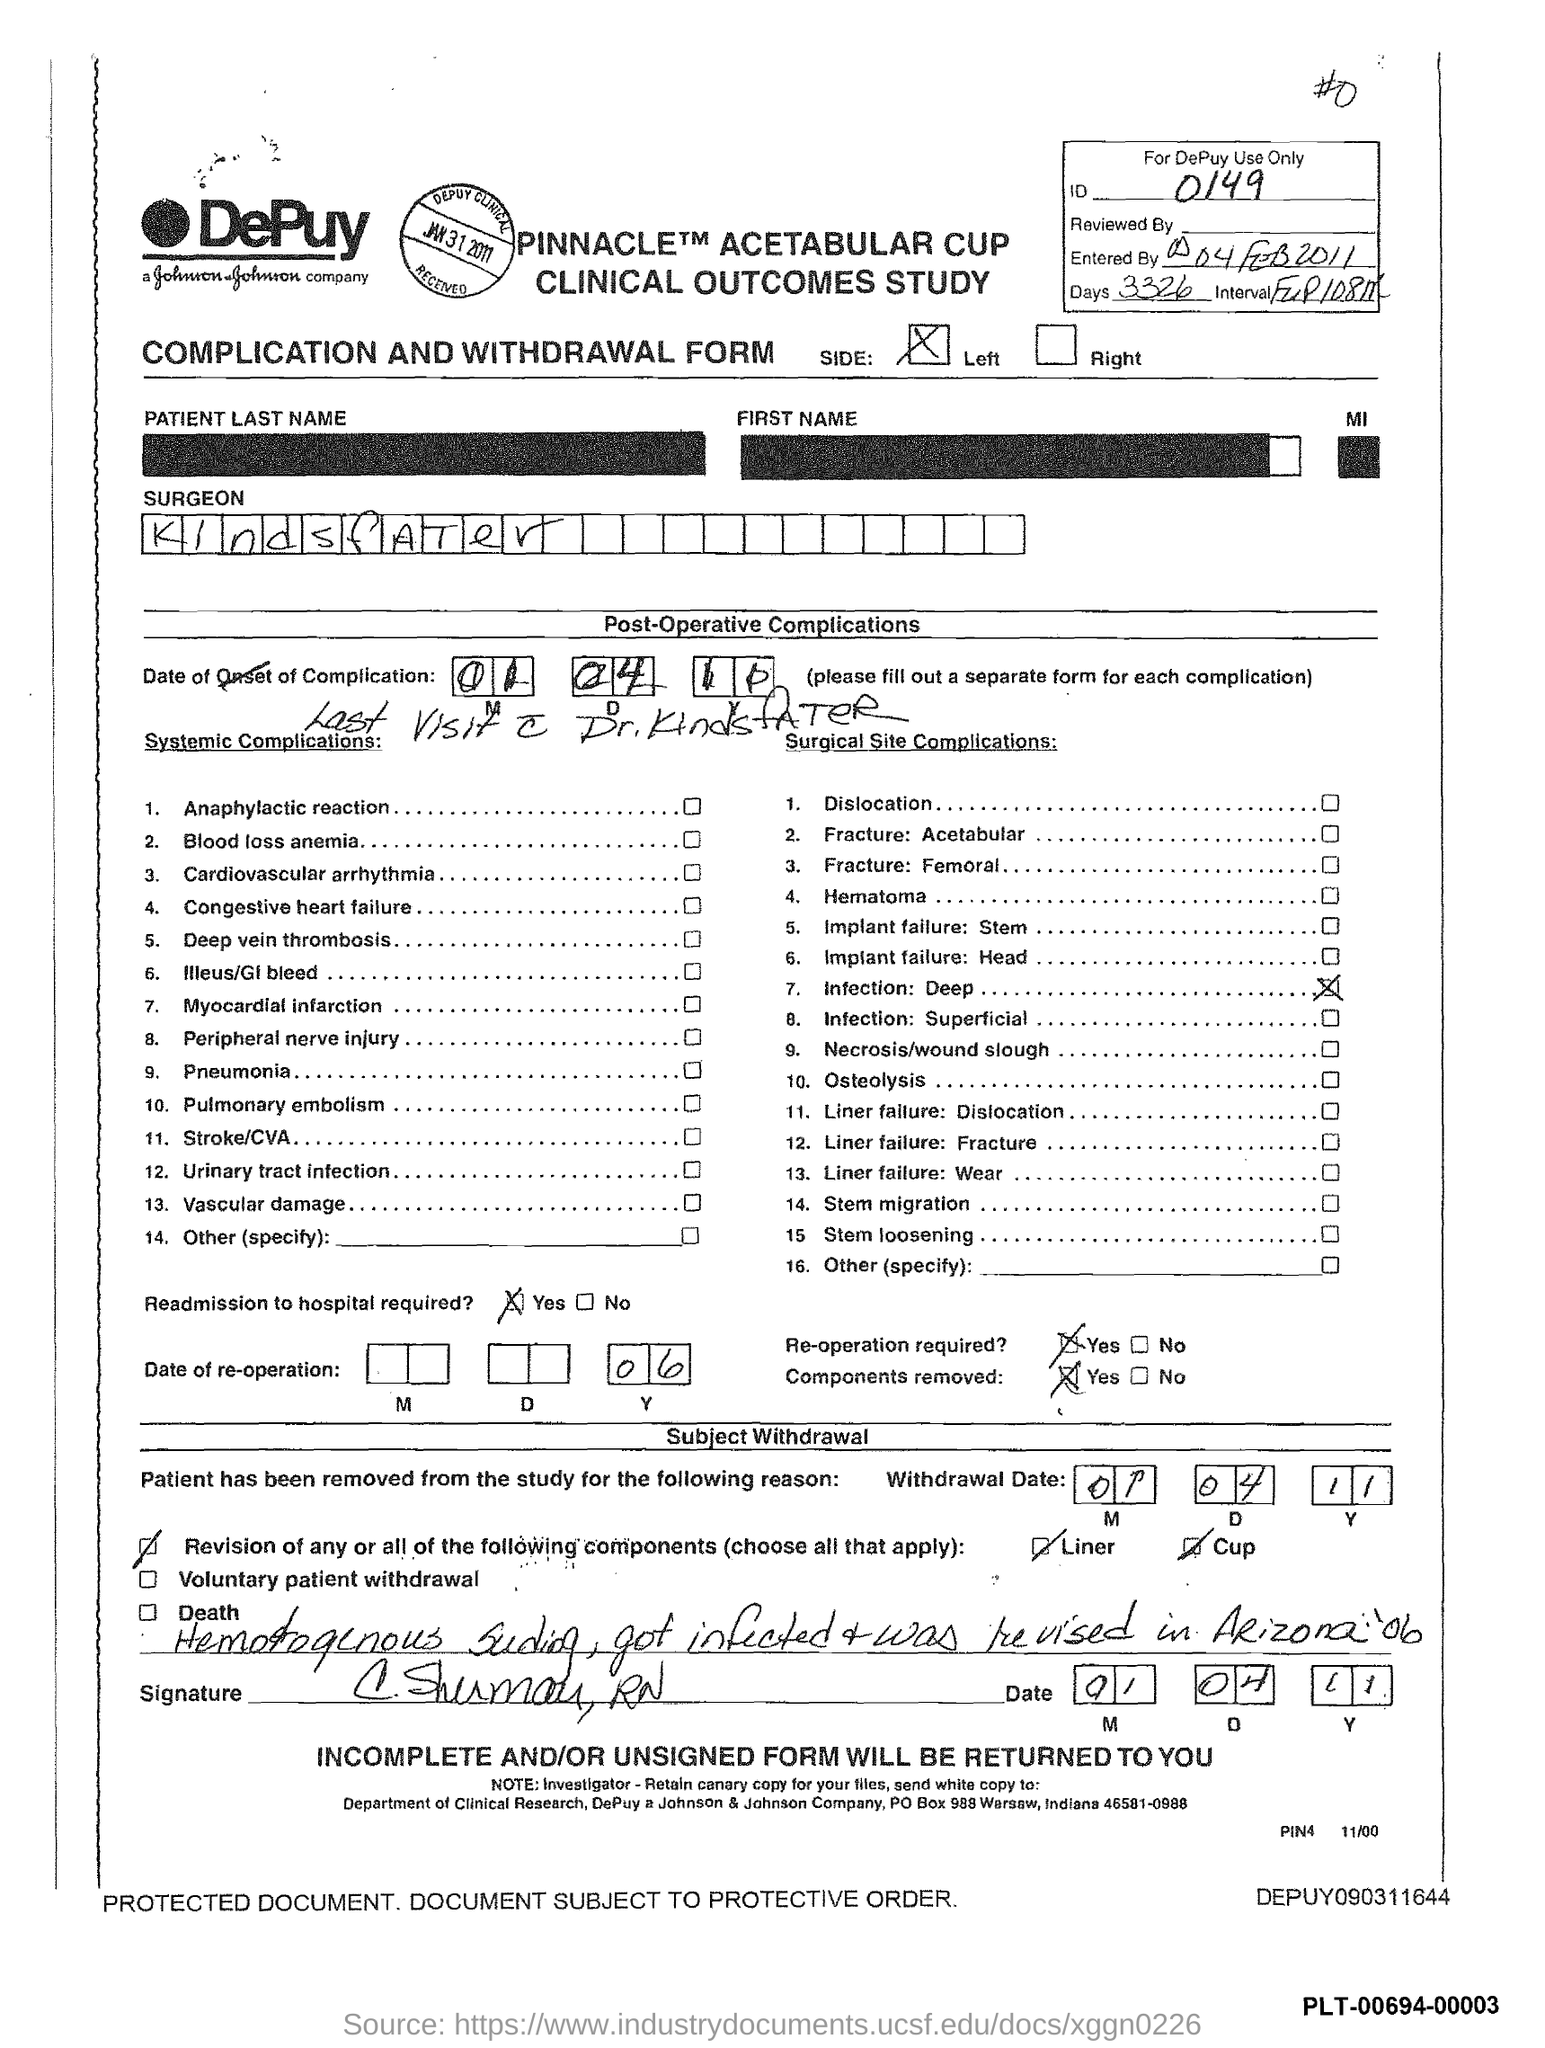What is the ID Number?
Provide a short and direct response. 0149. What is the number of days?
Your answer should be compact. 3326. What is the name of the Surgeon?
Your answer should be compact. Kindsfater. 